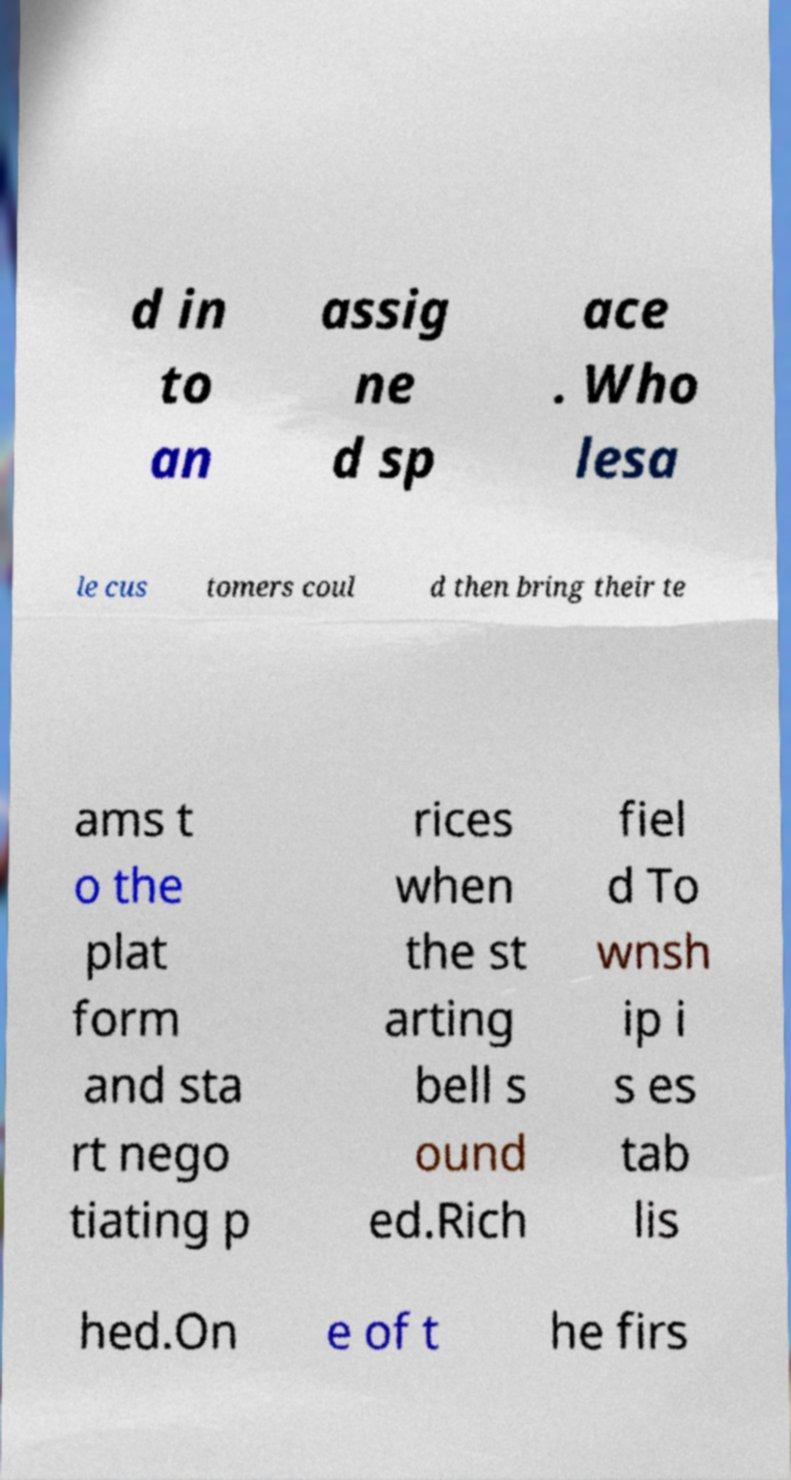Could you extract and type out the text from this image? d in to an assig ne d sp ace . Who lesa le cus tomers coul d then bring their te ams t o the plat form and sta rt nego tiating p rices when the st arting bell s ound ed.Rich fiel d To wnsh ip i s es tab lis hed.On e of t he firs 